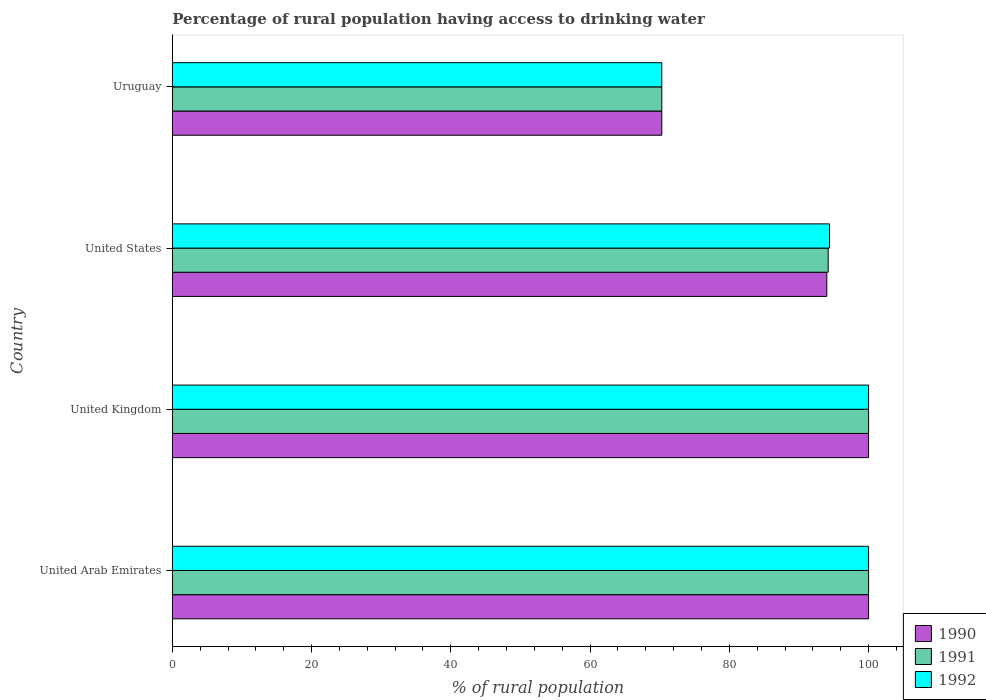How many different coloured bars are there?
Provide a succinct answer. 3. How many bars are there on the 3rd tick from the bottom?
Offer a terse response. 3. What is the label of the 2nd group of bars from the top?
Your answer should be very brief. United States. What is the percentage of rural population having access to drinking water in 1990 in United States?
Your answer should be compact. 94. Across all countries, what is the maximum percentage of rural population having access to drinking water in 1990?
Provide a succinct answer. 100. Across all countries, what is the minimum percentage of rural population having access to drinking water in 1991?
Your answer should be very brief. 70.3. In which country was the percentage of rural population having access to drinking water in 1990 maximum?
Keep it short and to the point. United Arab Emirates. In which country was the percentage of rural population having access to drinking water in 1990 minimum?
Your answer should be very brief. Uruguay. What is the total percentage of rural population having access to drinking water in 1991 in the graph?
Your answer should be very brief. 364.5. What is the difference between the percentage of rural population having access to drinking water in 1992 in United States and that in Uruguay?
Make the answer very short. 24.1. What is the difference between the percentage of rural population having access to drinking water in 1991 in United States and the percentage of rural population having access to drinking water in 1992 in United Arab Emirates?
Keep it short and to the point. -5.8. What is the average percentage of rural population having access to drinking water in 1992 per country?
Make the answer very short. 91.17. In how many countries, is the percentage of rural population having access to drinking water in 1992 greater than 100 %?
Your answer should be compact. 0. What is the ratio of the percentage of rural population having access to drinking water in 1992 in United Arab Emirates to that in United States?
Offer a terse response. 1.06. Is the difference between the percentage of rural population having access to drinking water in 1992 in United Arab Emirates and United States greater than the difference between the percentage of rural population having access to drinking water in 1990 in United Arab Emirates and United States?
Provide a short and direct response. No. What is the difference between the highest and the second highest percentage of rural population having access to drinking water in 1992?
Your response must be concise. 0. What is the difference between the highest and the lowest percentage of rural population having access to drinking water in 1990?
Ensure brevity in your answer.  29.7. In how many countries, is the percentage of rural population having access to drinking water in 1991 greater than the average percentage of rural population having access to drinking water in 1991 taken over all countries?
Ensure brevity in your answer.  3. Is the sum of the percentage of rural population having access to drinking water in 1992 in United Arab Emirates and United States greater than the maximum percentage of rural population having access to drinking water in 1990 across all countries?
Ensure brevity in your answer.  Yes. What does the 3rd bar from the top in United States represents?
Make the answer very short. 1990. What does the 2nd bar from the bottom in United Arab Emirates represents?
Your answer should be compact. 1991. Is it the case that in every country, the sum of the percentage of rural population having access to drinking water in 1991 and percentage of rural population having access to drinking water in 1992 is greater than the percentage of rural population having access to drinking water in 1990?
Your answer should be compact. Yes. How many bars are there?
Offer a terse response. 12. How many countries are there in the graph?
Offer a very short reply. 4. Are the values on the major ticks of X-axis written in scientific E-notation?
Ensure brevity in your answer.  No. Where does the legend appear in the graph?
Your answer should be compact. Bottom right. What is the title of the graph?
Offer a very short reply. Percentage of rural population having access to drinking water. Does "1987" appear as one of the legend labels in the graph?
Provide a succinct answer. No. What is the label or title of the X-axis?
Your answer should be very brief. % of rural population. What is the % of rural population in 1990 in United Arab Emirates?
Give a very brief answer. 100. What is the % of rural population of 1991 in United Arab Emirates?
Provide a short and direct response. 100. What is the % of rural population in 1992 in United Arab Emirates?
Provide a succinct answer. 100. What is the % of rural population of 1990 in United States?
Your answer should be compact. 94. What is the % of rural population in 1991 in United States?
Ensure brevity in your answer.  94.2. What is the % of rural population of 1992 in United States?
Keep it short and to the point. 94.4. What is the % of rural population of 1990 in Uruguay?
Your answer should be very brief. 70.3. What is the % of rural population in 1991 in Uruguay?
Provide a succinct answer. 70.3. What is the % of rural population in 1992 in Uruguay?
Your answer should be compact. 70.3. Across all countries, what is the maximum % of rural population in 1991?
Offer a very short reply. 100. Across all countries, what is the minimum % of rural population in 1990?
Keep it short and to the point. 70.3. Across all countries, what is the minimum % of rural population of 1991?
Your response must be concise. 70.3. Across all countries, what is the minimum % of rural population of 1992?
Offer a terse response. 70.3. What is the total % of rural population of 1990 in the graph?
Offer a terse response. 364.3. What is the total % of rural population of 1991 in the graph?
Keep it short and to the point. 364.5. What is the total % of rural population in 1992 in the graph?
Keep it short and to the point. 364.7. What is the difference between the % of rural population of 1991 in United Arab Emirates and that in United Kingdom?
Keep it short and to the point. 0. What is the difference between the % of rural population of 1990 in United Arab Emirates and that in United States?
Keep it short and to the point. 6. What is the difference between the % of rural population of 1991 in United Arab Emirates and that in United States?
Make the answer very short. 5.8. What is the difference between the % of rural population of 1992 in United Arab Emirates and that in United States?
Make the answer very short. 5.6. What is the difference between the % of rural population of 1990 in United Arab Emirates and that in Uruguay?
Give a very brief answer. 29.7. What is the difference between the % of rural population of 1991 in United Arab Emirates and that in Uruguay?
Offer a very short reply. 29.7. What is the difference between the % of rural population in 1992 in United Arab Emirates and that in Uruguay?
Offer a very short reply. 29.7. What is the difference between the % of rural population of 1990 in United Kingdom and that in United States?
Make the answer very short. 6. What is the difference between the % of rural population in 1991 in United Kingdom and that in United States?
Your answer should be very brief. 5.8. What is the difference between the % of rural population of 1992 in United Kingdom and that in United States?
Your answer should be very brief. 5.6. What is the difference between the % of rural population in 1990 in United Kingdom and that in Uruguay?
Provide a short and direct response. 29.7. What is the difference between the % of rural population of 1991 in United Kingdom and that in Uruguay?
Your answer should be compact. 29.7. What is the difference between the % of rural population in 1992 in United Kingdom and that in Uruguay?
Keep it short and to the point. 29.7. What is the difference between the % of rural population of 1990 in United States and that in Uruguay?
Provide a short and direct response. 23.7. What is the difference between the % of rural population of 1991 in United States and that in Uruguay?
Your answer should be very brief. 23.9. What is the difference between the % of rural population of 1992 in United States and that in Uruguay?
Provide a short and direct response. 24.1. What is the difference between the % of rural population of 1990 in United Arab Emirates and the % of rural population of 1992 in United Kingdom?
Your response must be concise. 0. What is the difference between the % of rural population in 1991 in United Arab Emirates and the % of rural population in 1992 in United Kingdom?
Your answer should be very brief. 0. What is the difference between the % of rural population in 1990 in United Arab Emirates and the % of rural population in 1992 in United States?
Give a very brief answer. 5.6. What is the difference between the % of rural population of 1991 in United Arab Emirates and the % of rural population of 1992 in United States?
Provide a short and direct response. 5.6. What is the difference between the % of rural population of 1990 in United Arab Emirates and the % of rural population of 1991 in Uruguay?
Provide a short and direct response. 29.7. What is the difference between the % of rural population in 1990 in United Arab Emirates and the % of rural population in 1992 in Uruguay?
Offer a terse response. 29.7. What is the difference between the % of rural population in 1991 in United Arab Emirates and the % of rural population in 1992 in Uruguay?
Offer a very short reply. 29.7. What is the difference between the % of rural population in 1990 in United Kingdom and the % of rural population in 1992 in United States?
Give a very brief answer. 5.6. What is the difference between the % of rural population in 1990 in United Kingdom and the % of rural population in 1991 in Uruguay?
Give a very brief answer. 29.7. What is the difference between the % of rural population in 1990 in United Kingdom and the % of rural population in 1992 in Uruguay?
Your response must be concise. 29.7. What is the difference between the % of rural population of 1991 in United Kingdom and the % of rural population of 1992 in Uruguay?
Provide a succinct answer. 29.7. What is the difference between the % of rural population of 1990 in United States and the % of rural population of 1991 in Uruguay?
Offer a very short reply. 23.7. What is the difference between the % of rural population in 1990 in United States and the % of rural population in 1992 in Uruguay?
Keep it short and to the point. 23.7. What is the difference between the % of rural population of 1991 in United States and the % of rural population of 1992 in Uruguay?
Your answer should be very brief. 23.9. What is the average % of rural population of 1990 per country?
Provide a short and direct response. 91.08. What is the average % of rural population in 1991 per country?
Ensure brevity in your answer.  91.12. What is the average % of rural population of 1992 per country?
Offer a terse response. 91.17. What is the difference between the % of rural population in 1991 and % of rural population in 1992 in United Arab Emirates?
Keep it short and to the point. 0. What is the difference between the % of rural population of 1990 and % of rural population of 1991 in United Kingdom?
Make the answer very short. 0. What is the difference between the % of rural population in 1991 and % of rural population in 1992 in United Kingdom?
Offer a terse response. 0. What is the difference between the % of rural population of 1990 and % of rural population of 1991 in United States?
Your answer should be compact. -0.2. What is the difference between the % of rural population of 1990 and % of rural population of 1992 in United States?
Your answer should be compact. -0.4. What is the difference between the % of rural population in 1990 and % of rural population in 1991 in Uruguay?
Provide a succinct answer. 0. What is the difference between the % of rural population in 1990 and % of rural population in 1992 in Uruguay?
Offer a very short reply. 0. What is the ratio of the % of rural population in 1990 in United Arab Emirates to that in United Kingdom?
Your answer should be compact. 1. What is the ratio of the % of rural population in 1990 in United Arab Emirates to that in United States?
Your response must be concise. 1.06. What is the ratio of the % of rural population of 1991 in United Arab Emirates to that in United States?
Keep it short and to the point. 1.06. What is the ratio of the % of rural population of 1992 in United Arab Emirates to that in United States?
Your answer should be compact. 1.06. What is the ratio of the % of rural population in 1990 in United Arab Emirates to that in Uruguay?
Your response must be concise. 1.42. What is the ratio of the % of rural population in 1991 in United Arab Emirates to that in Uruguay?
Offer a very short reply. 1.42. What is the ratio of the % of rural population of 1992 in United Arab Emirates to that in Uruguay?
Make the answer very short. 1.42. What is the ratio of the % of rural population in 1990 in United Kingdom to that in United States?
Provide a succinct answer. 1.06. What is the ratio of the % of rural population of 1991 in United Kingdom to that in United States?
Provide a succinct answer. 1.06. What is the ratio of the % of rural population in 1992 in United Kingdom to that in United States?
Make the answer very short. 1.06. What is the ratio of the % of rural population in 1990 in United Kingdom to that in Uruguay?
Provide a short and direct response. 1.42. What is the ratio of the % of rural population of 1991 in United Kingdom to that in Uruguay?
Give a very brief answer. 1.42. What is the ratio of the % of rural population of 1992 in United Kingdom to that in Uruguay?
Provide a succinct answer. 1.42. What is the ratio of the % of rural population of 1990 in United States to that in Uruguay?
Offer a very short reply. 1.34. What is the ratio of the % of rural population in 1991 in United States to that in Uruguay?
Your answer should be compact. 1.34. What is the ratio of the % of rural population in 1992 in United States to that in Uruguay?
Provide a short and direct response. 1.34. What is the difference between the highest and the second highest % of rural population in 1990?
Offer a very short reply. 0. What is the difference between the highest and the lowest % of rural population in 1990?
Provide a short and direct response. 29.7. What is the difference between the highest and the lowest % of rural population of 1991?
Your answer should be very brief. 29.7. What is the difference between the highest and the lowest % of rural population of 1992?
Ensure brevity in your answer.  29.7. 